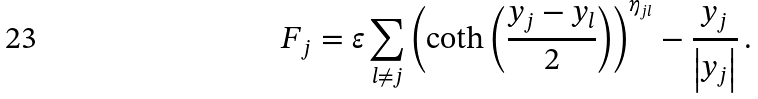<formula> <loc_0><loc_0><loc_500><loc_500>F _ { j } = \varepsilon \sum _ { l \neq j } \left ( \coth \left ( \frac { y _ { j } - y _ { l } } { 2 } \right ) \right ) ^ { \eta _ { j l } } - \frac { y _ { j } } { \left | y _ { j } \right | } \, .</formula> 